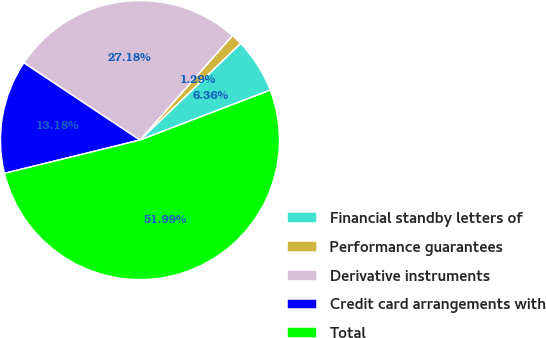Convert chart to OTSL. <chart><loc_0><loc_0><loc_500><loc_500><pie_chart><fcel>Financial standby letters of<fcel>Performance guarantees<fcel>Derivative instruments<fcel>Credit card arrangements with<fcel>Total<nl><fcel>6.36%<fcel>1.29%<fcel>27.19%<fcel>13.18%<fcel>52.0%<nl></chart> 